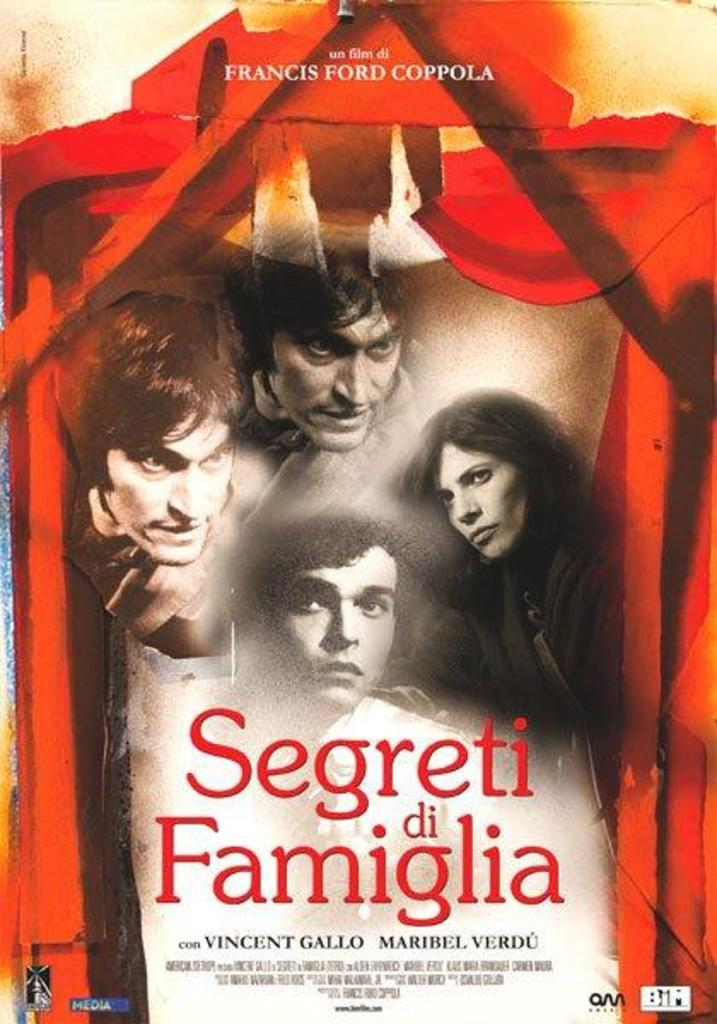<image>
Present a compact description of the photo's key features. Four people look off into the distance on a movie poster for Segreti di Famiglia. 